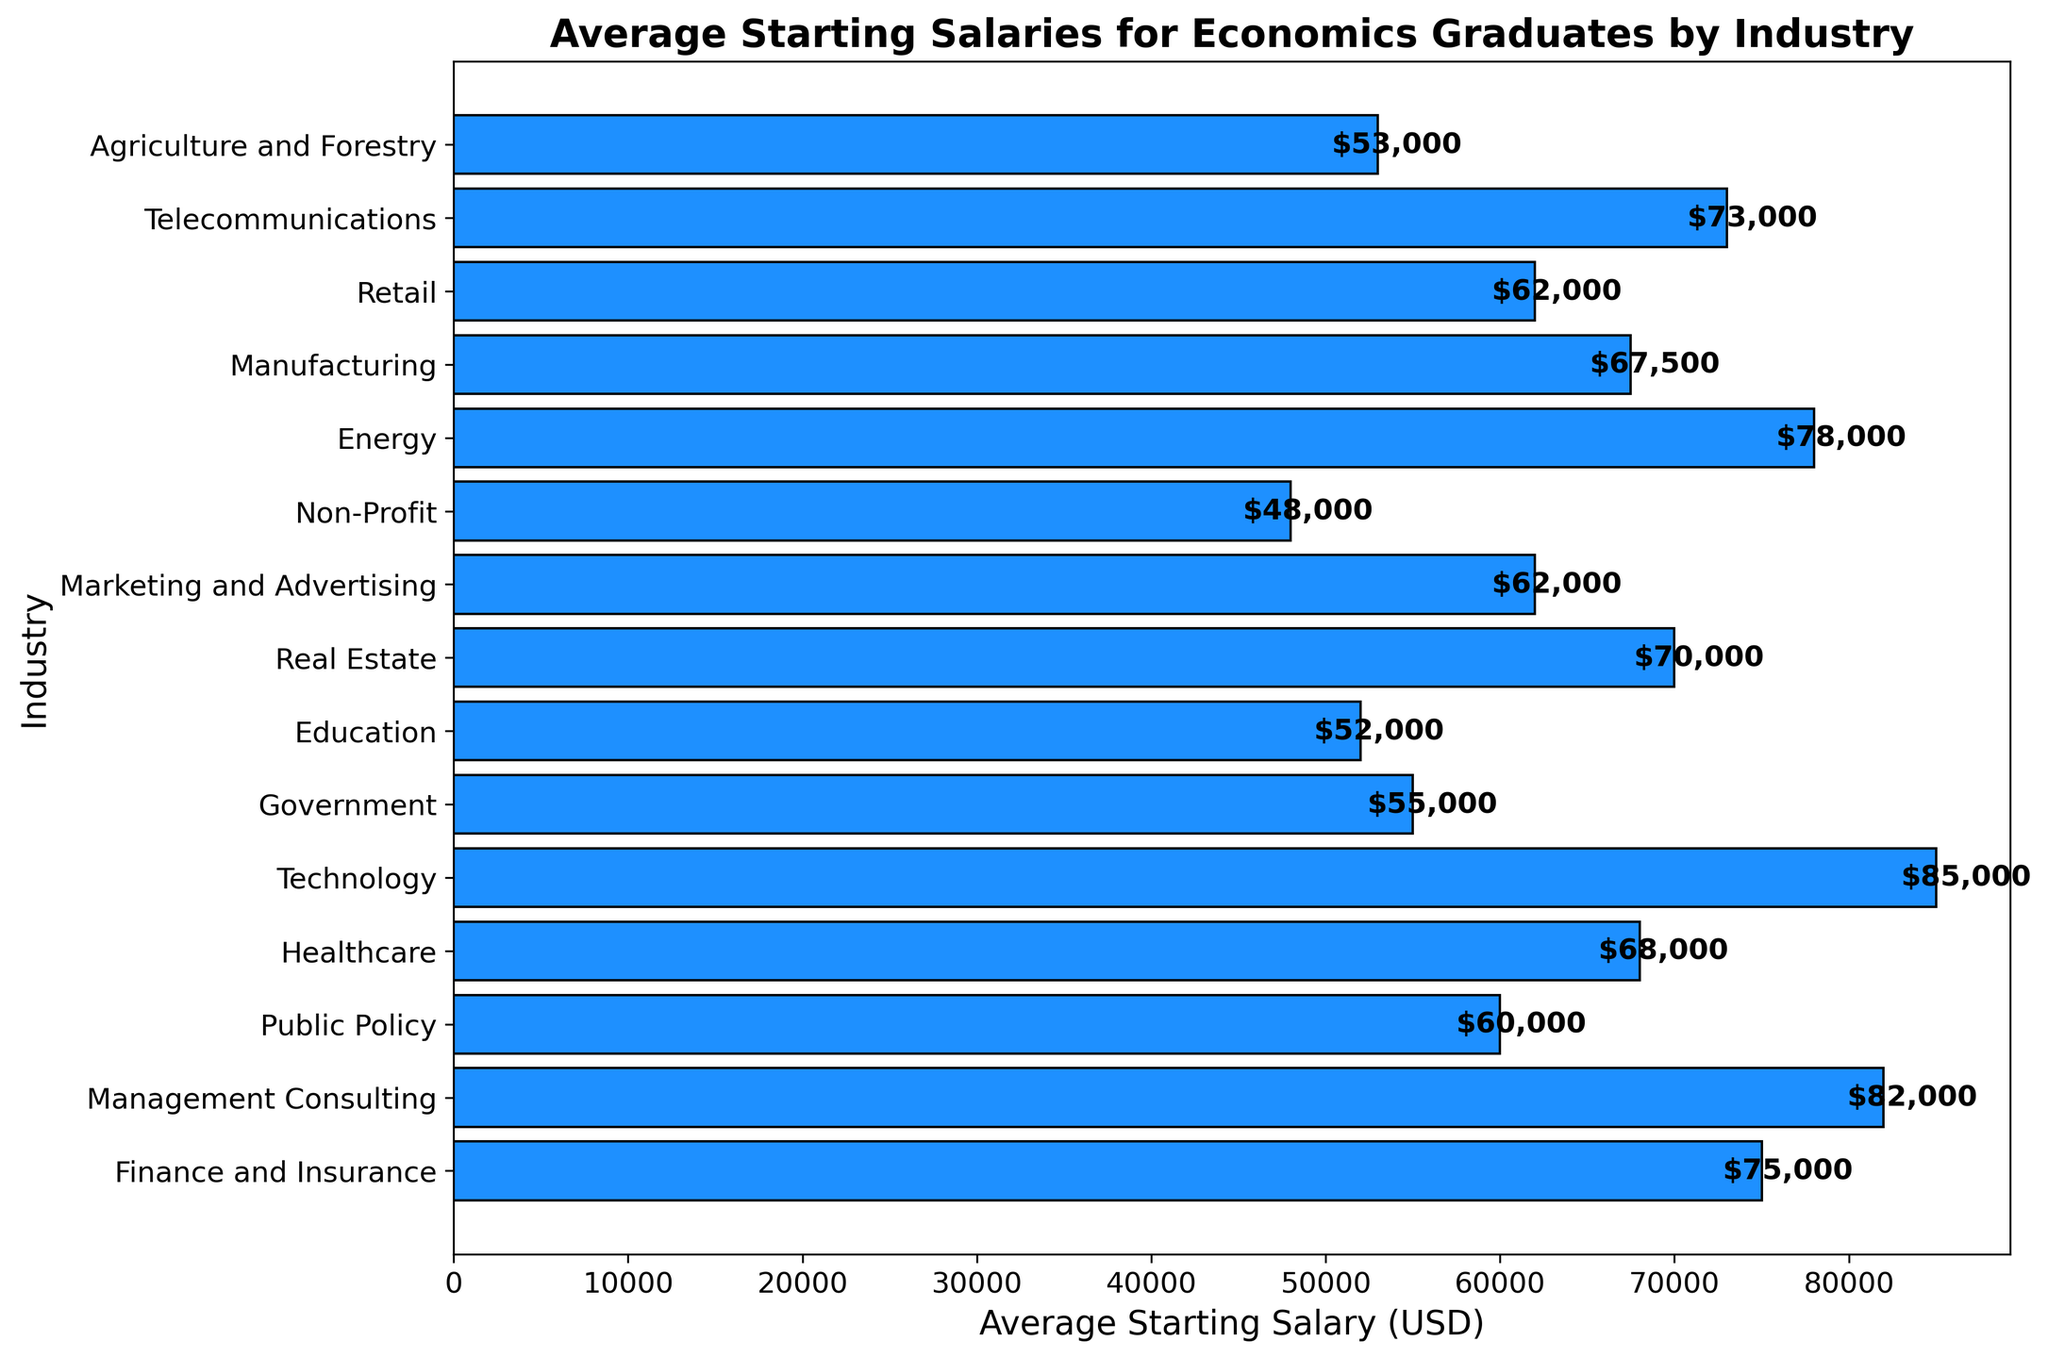What's the industry with the highest average starting salary? The figure shows the average starting salaries for various industries, and we can see that the bar for Technology is the longest, indicating the highest average starting salary.
Answer: Technology Which industry has a higher average starting salary, Finance and Insurance or Real Estate? Compare the lengths of the bars for Finance and Insurance and Real Estate. Finance and Insurance has a longer bar, indicating a higher average starting salary.
Answer: Finance and Insurance What is the difference in average starting salary between Technology and Non-Profit? The bar for Technology shows an average starting salary of $85,000, and the bar for Non-Profit shows $48,000. The difference is calculated as $85,000 - $48,000.
Answer: $37,000 What is the total average starting salary for industries related to Healthcare, Government, and Education? The figure shows: Healthcare ($68,000), Government ($55,000), and Education ($52,000). Sum these values: $68,000 + $55,000 + $52,000.
Answer: $175,000 Which has a lower average starting salary: Marketing and Advertising or Retail? Compare the lengths of the bars for Marketing and Advertising ($62,000) and Retail ($62,000). Both bars are the same length, indicating they have the same average starting salary.
Answer: Both are equal What is the median average starting salary among all the listed industries? First, list the salaries in ascending order: $48,000, $52,000, $53,000, $55,000, $60,000, $62,000, $62,000, $67,500, $68,000, $70,000, $73,000, $75,000, $78,000, $82,000, $85,000. Since there are 15 data points, the median is the 8th value.
Answer: $67,500 Which industry has the smallest average starting salary and what is it? The figure displays the smallest bar for Non-Profit, indicating the smallest average starting salary of $48,000.
Answer: Non-Profit, $48,000 How many industries have an average starting salary greater than $70,000? From the figure, count bars with values greater than $70,000: Finance and Insurance, Management Consulting, Technology, Energy, Telecommunications.
Answer: 5 What is the combined average starting salary of the top three highest paying industries? The top three highest percentages from the figure are Technology ($85,000), Management Consulting ($82,000), and Energy ($78,000). Sum these values: $85,000 + $82,000 + $78,000.
Answer: $245,000 Which industry shows an average starting salary closest to the overall average across all industries? First, calculate the average across all industries: ($75,000 + $82,000 + $60,000 + $68,000 + $85,000 + $55,000 + $52,000 + $70,000 + $62,000 + $48,000 + $78,000 + $67,500 + $62,000 + $73,000 + $53,000) / 15 = $65,433.3. Compare this to each industry finding the closest one: Healthcare ($68,000) is closest.
Answer: Healthcare 